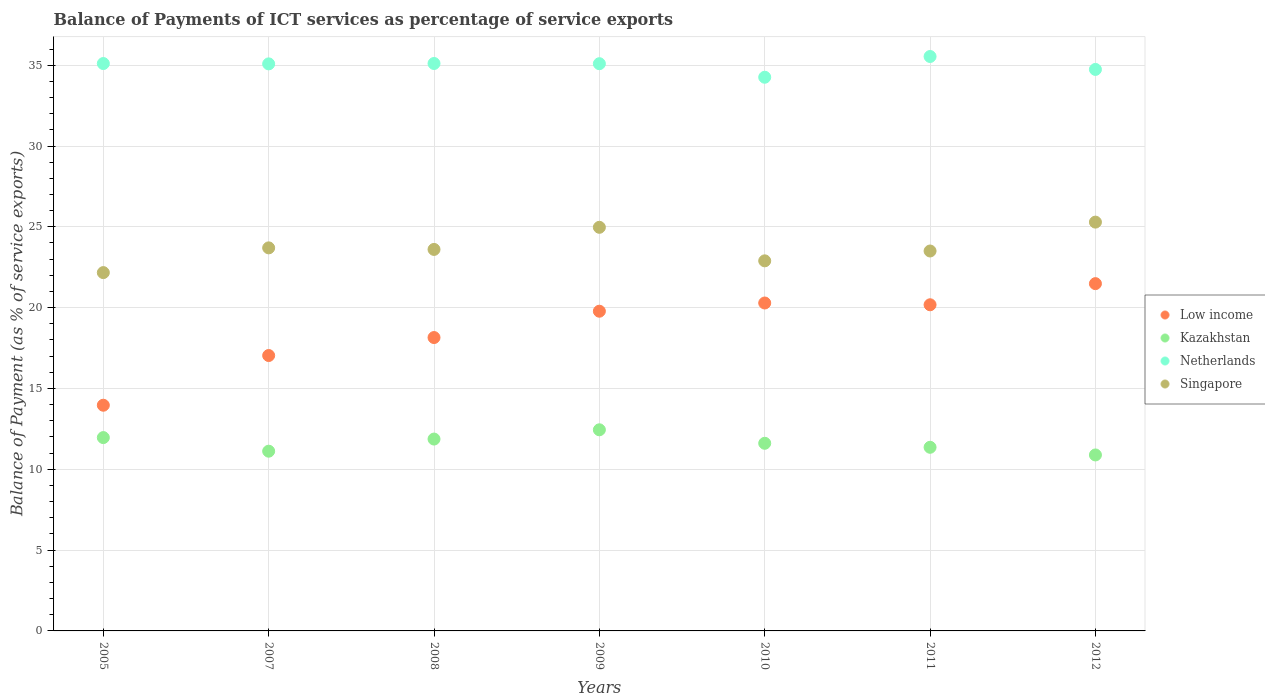Is the number of dotlines equal to the number of legend labels?
Your response must be concise. Yes. What is the balance of payments of ICT services in Netherlands in 2011?
Offer a terse response. 35.54. Across all years, what is the maximum balance of payments of ICT services in Netherlands?
Give a very brief answer. 35.54. Across all years, what is the minimum balance of payments of ICT services in Singapore?
Provide a succinct answer. 22.17. In which year was the balance of payments of ICT services in Kazakhstan maximum?
Provide a short and direct response. 2009. What is the total balance of payments of ICT services in Singapore in the graph?
Make the answer very short. 166.13. What is the difference between the balance of payments of ICT services in Netherlands in 2009 and that in 2011?
Keep it short and to the point. -0.45. What is the difference between the balance of payments of ICT services in Low income in 2009 and the balance of payments of ICT services in Singapore in 2008?
Make the answer very short. -3.82. What is the average balance of payments of ICT services in Low income per year?
Your answer should be compact. 18.7. In the year 2012, what is the difference between the balance of payments of ICT services in Kazakhstan and balance of payments of ICT services in Netherlands?
Offer a terse response. -23.85. What is the ratio of the balance of payments of ICT services in Kazakhstan in 2005 to that in 2009?
Your answer should be compact. 0.96. What is the difference between the highest and the second highest balance of payments of ICT services in Singapore?
Make the answer very short. 0.32. What is the difference between the highest and the lowest balance of payments of ICT services in Kazakhstan?
Ensure brevity in your answer.  1.56. In how many years, is the balance of payments of ICT services in Low income greater than the average balance of payments of ICT services in Low income taken over all years?
Your answer should be compact. 4. Is it the case that in every year, the sum of the balance of payments of ICT services in Netherlands and balance of payments of ICT services in Singapore  is greater than the balance of payments of ICT services in Low income?
Offer a very short reply. Yes. Is the balance of payments of ICT services in Netherlands strictly greater than the balance of payments of ICT services in Singapore over the years?
Make the answer very short. Yes. How many years are there in the graph?
Make the answer very short. 7. Are the values on the major ticks of Y-axis written in scientific E-notation?
Make the answer very short. No. Where does the legend appear in the graph?
Your answer should be very brief. Center right. What is the title of the graph?
Offer a terse response. Balance of Payments of ICT services as percentage of service exports. Does "Tunisia" appear as one of the legend labels in the graph?
Keep it short and to the point. No. What is the label or title of the X-axis?
Make the answer very short. Years. What is the label or title of the Y-axis?
Provide a succinct answer. Balance of Payment (as % of service exports). What is the Balance of Payment (as % of service exports) in Low income in 2005?
Offer a terse response. 13.96. What is the Balance of Payment (as % of service exports) in Kazakhstan in 2005?
Offer a very short reply. 11.96. What is the Balance of Payment (as % of service exports) in Netherlands in 2005?
Provide a succinct answer. 35.1. What is the Balance of Payment (as % of service exports) in Singapore in 2005?
Offer a terse response. 22.17. What is the Balance of Payment (as % of service exports) in Low income in 2007?
Your response must be concise. 17.04. What is the Balance of Payment (as % of service exports) in Kazakhstan in 2007?
Give a very brief answer. 11.12. What is the Balance of Payment (as % of service exports) of Netherlands in 2007?
Offer a very short reply. 35.08. What is the Balance of Payment (as % of service exports) in Singapore in 2007?
Give a very brief answer. 23.7. What is the Balance of Payment (as % of service exports) of Low income in 2008?
Your answer should be compact. 18.15. What is the Balance of Payment (as % of service exports) in Kazakhstan in 2008?
Your answer should be compact. 11.87. What is the Balance of Payment (as % of service exports) of Netherlands in 2008?
Provide a short and direct response. 35.11. What is the Balance of Payment (as % of service exports) of Singapore in 2008?
Your response must be concise. 23.6. What is the Balance of Payment (as % of service exports) of Low income in 2009?
Your answer should be very brief. 19.78. What is the Balance of Payment (as % of service exports) of Kazakhstan in 2009?
Give a very brief answer. 12.44. What is the Balance of Payment (as % of service exports) of Netherlands in 2009?
Provide a short and direct response. 35.09. What is the Balance of Payment (as % of service exports) of Singapore in 2009?
Provide a succinct answer. 24.97. What is the Balance of Payment (as % of service exports) in Low income in 2010?
Your answer should be compact. 20.29. What is the Balance of Payment (as % of service exports) in Kazakhstan in 2010?
Your response must be concise. 11.61. What is the Balance of Payment (as % of service exports) of Netherlands in 2010?
Offer a very short reply. 34.25. What is the Balance of Payment (as % of service exports) of Singapore in 2010?
Provide a short and direct response. 22.9. What is the Balance of Payment (as % of service exports) of Low income in 2011?
Your answer should be compact. 20.18. What is the Balance of Payment (as % of service exports) of Kazakhstan in 2011?
Your answer should be very brief. 11.36. What is the Balance of Payment (as % of service exports) of Netherlands in 2011?
Make the answer very short. 35.54. What is the Balance of Payment (as % of service exports) in Singapore in 2011?
Your answer should be compact. 23.5. What is the Balance of Payment (as % of service exports) of Low income in 2012?
Your answer should be compact. 21.49. What is the Balance of Payment (as % of service exports) of Kazakhstan in 2012?
Your answer should be very brief. 10.89. What is the Balance of Payment (as % of service exports) in Netherlands in 2012?
Offer a terse response. 34.74. What is the Balance of Payment (as % of service exports) of Singapore in 2012?
Your answer should be very brief. 25.29. Across all years, what is the maximum Balance of Payment (as % of service exports) of Low income?
Ensure brevity in your answer.  21.49. Across all years, what is the maximum Balance of Payment (as % of service exports) of Kazakhstan?
Keep it short and to the point. 12.44. Across all years, what is the maximum Balance of Payment (as % of service exports) of Netherlands?
Provide a short and direct response. 35.54. Across all years, what is the maximum Balance of Payment (as % of service exports) of Singapore?
Offer a terse response. 25.29. Across all years, what is the minimum Balance of Payment (as % of service exports) of Low income?
Give a very brief answer. 13.96. Across all years, what is the minimum Balance of Payment (as % of service exports) in Kazakhstan?
Make the answer very short. 10.89. Across all years, what is the minimum Balance of Payment (as % of service exports) in Netherlands?
Your answer should be very brief. 34.25. Across all years, what is the minimum Balance of Payment (as % of service exports) in Singapore?
Your answer should be compact. 22.17. What is the total Balance of Payment (as % of service exports) of Low income in the graph?
Provide a short and direct response. 130.88. What is the total Balance of Payment (as % of service exports) of Kazakhstan in the graph?
Keep it short and to the point. 81.25. What is the total Balance of Payment (as % of service exports) of Netherlands in the graph?
Provide a succinct answer. 244.91. What is the total Balance of Payment (as % of service exports) of Singapore in the graph?
Provide a succinct answer. 166.13. What is the difference between the Balance of Payment (as % of service exports) in Low income in 2005 and that in 2007?
Ensure brevity in your answer.  -3.08. What is the difference between the Balance of Payment (as % of service exports) in Kazakhstan in 2005 and that in 2007?
Give a very brief answer. 0.84. What is the difference between the Balance of Payment (as % of service exports) of Netherlands in 2005 and that in 2007?
Your answer should be compact. 0.02. What is the difference between the Balance of Payment (as % of service exports) in Singapore in 2005 and that in 2007?
Keep it short and to the point. -1.53. What is the difference between the Balance of Payment (as % of service exports) in Low income in 2005 and that in 2008?
Provide a short and direct response. -4.19. What is the difference between the Balance of Payment (as % of service exports) of Kazakhstan in 2005 and that in 2008?
Make the answer very short. 0.09. What is the difference between the Balance of Payment (as % of service exports) of Netherlands in 2005 and that in 2008?
Provide a short and direct response. -0. What is the difference between the Balance of Payment (as % of service exports) of Singapore in 2005 and that in 2008?
Provide a short and direct response. -1.43. What is the difference between the Balance of Payment (as % of service exports) of Low income in 2005 and that in 2009?
Make the answer very short. -5.82. What is the difference between the Balance of Payment (as % of service exports) of Kazakhstan in 2005 and that in 2009?
Ensure brevity in your answer.  -0.48. What is the difference between the Balance of Payment (as % of service exports) of Netherlands in 2005 and that in 2009?
Provide a short and direct response. 0.01. What is the difference between the Balance of Payment (as % of service exports) of Singapore in 2005 and that in 2009?
Your answer should be very brief. -2.8. What is the difference between the Balance of Payment (as % of service exports) of Low income in 2005 and that in 2010?
Offer a very short reply. -6.32. What is the difference between the Balance of Payment (as % of service exports) of Kazakhstan in 2005 and that in 2010?
Give a very brief answer. 0.35. What is the difference between the Balance of Payment (as % of service exports) in Netherlands in 2005 and that in 2010?
Make the answer very short. 0.85. What is the difference between the Balance of Payment (as % of service exports) in Singapore in 2005 and that in 2010?
Offer a very short reply. -0.73. What is the difference between the Balance of Payment (as % of service exports) of Low income in 2005 and that in 2011?
Provide a succinct answer. -6.22. What is the difference between the Balance of Payment (as % of service exports) of Kazakhstan in 2005 and that in 2011?
Make the answer very short. 0.6. What is the difference between the Balance of Payment (as % of service exports) in Netherlands in 2005 and that in 2011?
Your answer should be compact. -0.44. What is the difference between the Balance of Payment (as % of service exports) of Singapore in 2005 and that in 2011?
Give a very brief answer. -1.34. What is the difference between the Balance of Payment (as % of service exports) of Low income in 2005 and that in 2012?
Offer a terse response. -7.52. What is the difference between the Balance of Payment (as % of service exports) in Kazakhstan in 2005 and that in 2012?
Keep it short and to the point. 1.07. What is the difference between the Balance of Payment (as % of service exports) of Netherlands in 2005 and that in 2012?
Your response must be concise. 0.36. What is the difference between the Balance of Payment (as % of service exports) in Singapore in 2005 and that in 2012?
Your answer should be compact. -3.12. What is the difference between the Balance of Payment (as % of service exports) in Low income in 2007 and that in 2008?
Your response must be concise. -1.11. What is the difference between the Balance of Payment (as % of service exports) in Kazakhstan in 2007 and that in 2008?
Make the answer very short. -0.75. What is the difference between the Balance of Payment (as % of service exports) in Netherlands in 2007 and that in 2008?
Your answer should be compact. -0.02. What is the difference between the Balance of Payment (as % of service exports) in Singapore in 2007 and that in 2008?
Your answer should be very brief. 0.1. What is the difference between the Balance of Payment (as % of service exports) in Low income in 2007 and that in 2009?
Your response must be concise. -2.74. What is the difference between the Balance of Payment (as % of service exports) in Kazakhstan in 2007 and that in 2009?
Make the answer very short. -1.32. What is the difference between the Balance of Payment (as % of service exports) in Netherlands in 2007 and that in 2009?
Your answer should be very brief. -0.01. What is the difference between the Balance of Payment (as % of service exports) of Singapore in 2007 and that in 2009?
Your answer should be very brief. -1.27. What is the difference between the Balance of Payment (as % of service exports) of Low income in 2007 and that in 2010?
Offer a terse response. -3.25. What is the difference between the Balance of Payment (as % of service exports) in Kazakhstan in 2007 and that in 2010?
Make the answer very short. -0.49. What is the difference between the Balance of Payment (as % of service exports) of Netherlands in 2007 and that in 2010?
Offer a very short reply. 0.83. What is the difference between the Balance of Payment (as % of service exports) of Singapore in 2007 and that in 2010?
Your answer should be compact. 0.8. What is the difference between the Balance of Payment (as % of service exports) in Low income in 2007 and that in 2011?
Offer a terse response. -3.14. What is the difference between the Balance of Payment (as % of service exports) in Kazakhstan in 2007 and that in 2011?
Your answer should be very brief. -0.24. What is the difference between the Balance of Payment (as % of service exports) in Netherlands in 2007 and that in 2011?
Keep it short and to the point. -0.46. What is the difference between the Balance of Payment (as % of service exports) of Singapore in 2007 and that in 2011?
Keep it short and to the point. 0.19. What is the difference between the Balance of Payment (as % of service exports) in Low income in 2007 and that in 2012?
Provide a short and direct response. -4.45. What is the difference between the Balance of Payment (as % of service exports) in Kazakhstan in 2007 and that in 2012?
Offer a very short reply. 0.23. What is the difference between the Balance of Payment (as % of service exports) of Netherlands in 2007 and that in 2012?
Your answer should be very brief. 0.34. What is the difference between the Balance of Payment (as % of service exports) of Singapore in 2007 and that in 2012?
Keep it short and to the point. -1.59. What is the difference between the Balance of Payment (as % of service exports) of Low income in 2008 and that in 2009?
Ensure brevity in your answer.  -1.63. What is the difference between the Balance of Payment (as % of service exports) in Kazakhstan in 2008 and that in 2009?
Ensure brevity in your answer.  -0.57. What is the difference between the Balance of Payment (as % of service exports) in Netherlands in 2008 and that in 2009?
Your answer should be compact. 0.01. What is the difference between the Balance of Payment (as % of service exports) of Singapore in 2008 and that in 2009?
Provide a succinct answer. -1.37. What is the difference between the Balance of Payment (as % of service exports) in Low income in 2008 and that in 2010?
Provide a succinct answer. -2.14. What is the difference between the Balance of Payment (as % of service exports) in Kazakhstan in 2008 and that in 2010?
Provide a succinct answer. 0.26. What is the difference between the Balance of Payment (as % of service exports) of Netherlands in 2008 and that in 2010?
Offer a terse response. 0.85. What is the difference between the Balance of Payment (as % of service exports) in Singapore in 2008 and that in 2010?
Make the answer very short. 0.71. What is the difference between the Balance of Payment (as % of service exports) of Low income in 2008 and that in 2011?
Offer a very short reply. -2.03. What is the difference between the Balance of Payment (as % of service exports) in Kazakhstan in 2008 and that in 2011?
Provide a succinct answer. 0.51. What is the difference between the Balance of Payment (as % of service exports) of Netherlands in 2008 and that in 2011?
Keep it short and to the point. -0.43. What is the difference between the Balance of Payment (as % of service exports) of Singapore in 2008 and that in 2011?
Offer a very short reply. 0.1. What is the difference between the Balance of Payment (as % of service exports) in Low income in 2008 and that in 2012?
Provide a short and direct response. -3.34. What is the difference between the Balance of Payment (as % of service exports) of Kazakhstan in 2008 and that in 2012?
Your answer should be very brief. 0.98. What is the difference between the Balance of Payment (as % of service exports) of Netherlands in 2008 and that in 2012?
Keep it short and to the point. 0.37. What is the difference between the Balance of Payment (as % of service exports) of Singapore in 2008 and that in 2012?
Give a very brief answer. -1.69. What is the difference between the Balance of Payment (as % of service exports) of Low income in 2009 and that in 2010?
Offer a very short reply. -0.51. What is the difference between the Balance of Payment (as % of service exports) of Kazakhstan in 2009 and that in 2010?
Make the answer very short. 0.83. What is the difference between the Balance of Payment (as % of service exports) of Netherlands in 2009 and that in 2010?
Your answer should be compact. 0.84. What is the difference between the Balance of Payment (as % of service exports) of Singapore in 2009 and that in 2010?
Offer a terse response. 2.07. What is the difference between the Balance of Payment (as % of service exports) in Low income in 2009 and that in 2011?
Give a very brief answer. -0.4. What is the difference between the Balance of Payment (as % of service exports) in Kazakhstan in 2009 and that in 2011?
Your response must be concise. 1.08. What is the difference between the Balance of Payment (as % of service exports) of Netherlands in 2009 and that in 2011?
Ensure brevity in your answer.  -0.45. What is the difference between the Balance of Payment (as % of service exports) in Singapore in 2009 and that in 2011?
Keep it short and to the point. 1.47. What is the difference between the Balance of Payment (as % of service exports) in Low income in 2009 and that in 2012?
Offer a very short reply. -1.71. What is the difference between the Balance of Payment (as % of service exports) of Kazakhstan in 2009 and that in 2012?
Your answer should be compact. 1.56. What is the difference between the Balance of Payment (as % of service exports) of Netherlands in 2009 and that in 2012?
Ensure brevity in your answer.  0.35. What is the difference between the Balance of Payment (as % of service exports) of Singapore in 2009 and that in 2012?
Offer a very short reply. -0.32. What is the difference between the Balance of Payment (as % of service exports) of Low income in 2010 and that in 2011?
Give a very brief answer. 0.11. What is the difference between the Balance of Payment (as % of service exports) in Kazakhstan in 2010 and that in 2011?
Make the answer very short. 0.25. What is the difference between the Balance of Payment (as % of service exports) in Netherlands in 2010 and that in 2011?
Your answer should be compact. -1.28. What is the difference between the Balance of Payment (as % of service exports) in Singapore in 2010 and that in 2011?
Keep it short and to the point. -0.61. What is the difference between the Balance of Payment (as % of service exports) in Low income in 2010 and that in 2012?
Ensure brevity in your answer.  -1.2. What is the difference between the Balance of Payment (as % of service exports) of Kazakhstan in 2010 and that in 2012?
Make the answer very short. 0.72. What is the difference between the Balance of Payment (as % of service exports) in Netherlands in 2010 and that in 2012?
Make the answer very short. -0.48. What is the difference between the Balance of Payment (as % of service exports) of Singapore in 2010 and that in 2012?
Your answer should be compact. -2.4. What is the difference between the Balance of Payment (as % of service exports) in Low income in 2011 and that in 2012?
Provide a short and direct response. -1.31. What is the difference between the Balance of Payment (as % of service exports) in Kazakhstan in 2011 and that in 2012?
Your response must be concise. 0.47. What is the difference between the Balance of Payment (as % of service exports) of Netherlands in 2011 and that in 2012?
Provide a succinct answer. 0.8. What is the difference between the Balance of Payment (as % of service exports) in Singapore in 2011 and that in 2012?
Your response must be concise. -1.79. What is the difference between the Balance of Payment (as % of service exports) of Low income in 2005 and the Balance of Payment (as % of service exports) of Kazakhstan in 2007?
Provide a succinct answer. 2.84. What is the difference between the Balance of Payment (as % of service exports) of Low income in 2005 and the Balance of Payment (as % of service exports) of Netherlands in 2007?
Offer a terse response. -21.12. What is the difference between the Balance of Payment (as % of service exports) in Low income in 2005 and the Balance of Payment (as % of service exports) in Singapore in 2007?
Ensure brevity in your answer.  -9.74. What is the difference between the Balance of Payment (as % of service exports) in Kazakhstan in 2005 and the Balance of Payment (as % of service exports) in Netherlands in 2007?
Keep it short and to the point. -23.12. What is the difference between the Balance of Payment (as % of service exports) in Kazakhstan in 2005 and the Balance of Payment (as % of service exports) in Singapore in 2007?
Give a very brief answer. -11.74. What is the difference between the Balance of Payment (as % of service exports) in Netherlands in 2005 and the Balance of Payment (as % of service exports) in Singapore in 2007?
Your answer should be compact. 11.4. What is the difference between the Balance of Payment (as % of service exports) in Low income in 2005 and the Balance of Payment (as % of service exports) in Kazakhstan in 2008?
Your answer should be very brief. 2.09. What is the difference between the Balance of Payment (as % of service exports) in Low income in 2005 and the Balance of Payment (as % of service exports) in Netherlands in 2008?
Provide a short and direct response. -21.14. What is the difference between the Balance of Payment (as % of service exports) of Low income in 2005 and the Balance of Payment (as % of service exports) of Singapore in 2008?
Your answer should be compact. -9.64. What is the difference between the Balance of Payment (as % of service exports) in Kazakhstan in 2005 and the Balance of Payment (as % of service exports) in Netherlands in 2008?
Offer a terse response. -23.14. What is the difference between the Balance of Payment (as % of service exports) in Kazakhstan in 2005 and the Balance of Payment (as % of service exports) in Singapore in 2008?
Ensure brevity in your answer.  -11.64. What is the difference between the Balance of Payment (as % of service exports) of Netherlands in 2005 and the Balance of Payment (as % of service exports) of Singapore in 2008?
Provide a succinct answer. 11.5. What is the difference between the Balance of Payment (as % of service exports) of Low income in 2005 and the Balance of Payment (as % of service exports) of Kazakhstan in 2009?
Keep it short and to the point. 1.52. What is the difference between the Balance of Payment (as % of service exports) in Low income in 2005 and the Balance of Payment (as % of service exports) in Netherlands in 2009?
Offer a very short reply. -21.13. What is the difference between the Balance of Payment (as % of service exports) of Low income in 2005 and the Balance of Payment (as % of service exports) of Singapore in 2009?
Ensure brevity in your answer.  -11.01. What is the difference between the Balance of Payment (as % of service exports) of Kazakhstan in 2005 and the Balance of Payment (as % of service exports) of Netherlands in 2009?
Provide a short and direct response. -23.13. What is the difference between the Balance of Payment (as % of service exports) in Kazakhstan in 2005 and the Balance of Payment (as % of service exports) in Singapore in 2009?
Your answer should be very brief. -13.01. What is the difference between the Balance of Payment (as % of service exports) of Netherlands in 2005 and the Balance of Payment (as % of service exports) of Singapore in 2009?
Give a very brief answer. 10.13. What is the difference between the Balance of Payment (as % of service exports) of Low income in 2005 and the Balance of Payment (as % of service exports) of Kazakhstan in 2010?
Provide a succinct answer. 2.35. What is the difference between the Balance of Payment (as % of service exports) in Low income in 2005 and the Balance of Payment (as % of service exports) in Netherlands in 2010?
Offer a terse response. -20.29. What is the difference between the Balance of Payment (as % of service exports) of Low income in 2005 and the Balance of Payment (as % of service exports) of Singapore in 2010?
Ensure brevity in your answer.  -8.93. What is the difference between the Balance of Payment (as % of service exports) of Kazakhstan in 2005 and the Balance of Payment (as % of service exports) of Netherlands in 2010?
Provide a succinct answer. -22.29. What is the difference between the Balance of Payment (as % of service exports) in Kazakhstan in 2005 and the Balance of Payment (as % of service exports) in Singapore in 2010?
Your response must be concise. -10.93. What is the difference between the Balance of Payment (as % of service exports) in Netherlands in 2005 and the Balance of Payment (as % of service exports) in Singapore in 2010?
Provide a short and direct response. 12.21. What is the difference between the Balance of Payment (as % of service exports) in Low income in 2005 and the Balance of Payment (as % of service exports) in Kazakhstan in 2011?
Provide a short and direct response. 2.6. What is the difference between the Balance of Payment (as % of service exports) of Low income in 2005 and the Balance of Payment (as % of service exports) of Netherlands in 2011?
Offer a terse response. -21.58. What is the difference between the Balance of Payment (as % of service exports) in Low income in 2005 and the Balance of Payment (as % of service exports) in Singapore in 2011?
Give a very brief answer. -9.54. What is the difference between the Balance of Payment (as % of service exports) of Kazakhstan in 2005 and the Balance of Payment (as % of service exports) of Netherlands in 2011?
Provide a succinct answer. -23.58. What is the difference between the Balance of Payment (as % of service exports) of Kazakhstan in 2005 and the Balance of Payment (as % of service exports) of Singapore in 2011?
Ensure brevity in your answer.  -11.54. What is the difference between the Balance of Payment (as % of service exports) of Netherlands in 2005 and the Balance of Payment (as % of service exports) of Singapore in 2011?
Keep it short and to the point. 11.6. What is the difference between the Balance of Payment (as % of service exports) of Low income in 2005 and the Balance of Payment (as % of service exports) of Kazakhstan in 2012?
Provide a succinct answer. 3.08. What is the difference between the Balance of Payment (as % of service exports) in Low income in 2005 and the Balance of Payment (as % of service exports) in Netherlands in 2012?
Keep it short and to the point. -20.78. What is the difference between the Balance of Payment (as % of service exports) of Low income in 2005 and the Balance of Payment (as % of service exports) of Singapore in 2012?
Offer a terse response. -11.33. What is the difference between the Balance of Payment (as % of service exports) of Kazakhstan in 2005 and the Balance of Payment (as % of service exports) of Netherlands in 2012?
Make the answer very short. -22.78. What is the difference between the Balance of Payment (as % of service exports) of Kazakhstan in 2005 and the Balance of Payment (as % of service exports) of Singapore in 2012?
Your response must be concise. -13.33. What is the difference between the Balance of Payment (as % of service exports) in Netherlands in 2005 and the Balance of Payment (as % of service exports) in Singapore in 2012?
Offer a very short reply. 9.81. What is the difference between the Balance of Payment (as % of service exports) in Low income in 2007 and the Balance of Payment (as % of service exports) in Kazakhstan in 2008?
Offer a very short reply. 5.17. What is the difference between the Balance of Payment (as % of service exports) in Low income in 2007 and the Balance of Payment (as % of service exports) in Netherlands in 2008?
Provide a short and direct response. -18.07. What is the difference between the Balance of Payment (as % of service exports) of Low income in 2007 and the Balance of Payment (as % of service exports) of Singapore in 2008?
Keep it short and to the point. -6.56. What is the difference between the Balance of Payment (as % of service exports) in Kazakhstan in 2007 and the Balance of Payment (as % of service exports) in Netherlands in 2008?
Provide a succinct answer. -23.99. What is the difference between the Balance of Payment (as % of service exports) in Kazakhstan in 2007 and the Balance of Payment (as % of service exports) in Singapore in 2008?
Keep it short and to the point. -12.48. What is the difference between the Balance of Payment (as % of service exports) of Netherlands in 2007 and the Balance of Payment (as % of service exports) of Singapore in 2008?
Provide a short and direct response. 11.48. What is the difference between the Balance of Payment (as % of service exports) in Low income in 2007 and the Balance of Payment (as % of service exports) in Kazakhstan in 2009?
Your response must be concise. 4.6. What is the difference between the Balance of Payment (as % of service exports) of Low income in 2007 and the Balance of Payment (as % of service exports) of Netherlands in 2009?
Make the answer very short. -18.05. What is the difference between the Balance of Payment (as % of service exports) in Low income in 2007 and the Balance of Payment (as % of service exports) in Singapore in 2009?
Offer a very short reply. -7.93. What is the difference between the Balance of Payment (as % of service exports) in Kazakhstan in 2007 and the Balance of Payment (as % of service exports) in Netherlands in 2009?
Provide a succinct answer. -23.97. What is the difference between the Balance of Payment (as % of service exports) of Kazakhstan in 2007 and the Balance of Payment (as % of service exports) of Singapore in 2009?
Your response must be concise. -13.85. What is the difference between the Balance of Payment (as % of service exports) of Netherlands in 2007 and the Balance of Payment (as % of service exports) of Singapore in 2009?
Provide a succinct answer. 10.11. What is the difference between the Balance of Payment (as % of service exports) of Low income in 2007 and the Balance of Payment (as % of service exports) of Kazakhstan in 2010?
Ensure brevity in your answer.  5.43. What is the difference between the Balance of Payment (as % of service exports) of Low income in 2007 and the Balance of Payment (as % of service exports) of Netherlands in 2010?
Offer a terse response. -17.22. What is the difference between the Balance of Payment (as % of service exports) in Low income in 2007 and the Balance of Payment (as % of service exports) in Singapore in 2010?
Make the answer very short. -5.86. What is the difference between the Balance of Payment (as % of service exports) in Kazakhstan in 2007 and the Balance of Payment (as % of service exports) in Netherlands in 2010?
Give a very brief answer. -23.13. What is the difference between the Balance of Payment (as % of service exports) in Kazakhstan in 2007 and the Balance of Payment (as % of service exports) in Singapore in 2010?
Give a very brief answer. -11.78. What is the difference between the Balance of Payment (as % of service exports) in Netherlands in 2007 and the Balance of Payment (as % of service exports) in Singapore in 2010?
Offer a terse response. 12.19. What is the difference between the Balance of Payment (as % of service exports) of Low income in 2007 and the Balance of Payment (as % of service exports) of Kazakhstan in 2011?
Your answer should be compact. 5.68. What is the difference between the Balance of Payment (as % of service exports) of Low income in 2007 and the Balance of Payment (as % of service exports) of Netherlands in 2011?
Give a very brief answer. -18.5. What is the difference between the Balance of Payment (as % of service exports) of Low income in 2007 and the Balance of Payment (as % of service exports) of Singapore in 2011?
Give a very brief answer. -6.47. What is the difference between the Balance of Payment (as % of service exports) in Kazakhstan in 2007 and the Balance of Payment (as % of service exports) in Netherlands in 2011?
Keep it short and to the point. -24.42. What is the difference between the Balance of Payment (as % of service exports) of Kazakhstan in 2007 and the Balance of Payment (as % of service exports) of Singapore in 2011?
Offer a very short reply. -12.38. What is the difference between the Balance of Payment (as % of service exports) of Netherlands in 2007 and the Balance of Payment (as % of service exports) of Singapore in 2011?
Provide a short and direct response. 11.58. What is the difference between the Balance of Payment (as % of service exports) in Low income in 2007 and the Balance of Payment (as % of service exports) in Kazakhstan in 2012?
Provide a short and direct response. 6.15. What is the difference between the Balance of Payment (as % of service exports) in Low income in 2007 and the Balance of Payment (as % of service exports) in Netherlands in 2012?
Your answer should be compact. -17.7. What is the difference between the Balance of Payment (as % of service exports) of Low income in 2007 and the Balance of Payment (as % of service exports) of Singapore in 2012?
Keep it short and to the point. -8.25. What is the difference between the Balance of Payment (as % of service exports) of Kazakhstan in 2007 and the Balance of Payment (as % of service exports) of Netherlands in 2012?
Your response must be concise. -23.62. What is the difference between the Balance of Payment (as % of service exports) of Kazakhstan in 2007 and the Balance of Payment (as % of service exports) of Singapore in 2012?
Provide a short and direct response. -14.17. What is the difference between the Balance of Payment (as % of service exports) of Netherlands in 2007 and the Balance of Payment (as % of service exports) of Singapore in 2012?
Provide a short and direct response. 9.79. What is the difference between the Balance of Payment (as % of service exports) in Low income in 2008 and the Balance of Payment (as % of service exports) in Kazakhstan in 2009?
Your answer should be compact. 5.71. What is the difference between the Balance of Payment (as % of service exports) in Low income in 2008 and the Balance of Payment (as % of service exports) in Netherlands in 2009?
Keep it short and to the point. -16.94. What is the difference between the Balance of Payment (as % of service exports) of Low income in 2008 and the Balance of Payment (as % of service exports) of Singapore in 2009?
Provide a succinct answer. -6.82. What is the difference between the Balance of Payment (as % of service exports) of Kazakhstan in 2008 and the Balance of Payment (as % of service exports) of Netherlands in 2009?
Provide a succinct answer. -23.22. What is the difference between the Balance of Payment (as % of service exports) in Kazakhstan in 2008 and the Balance of Payment (as % of service exports) in Singapore in 2009?
Offer a very short reply. -13.1. What is the difference between the Balance of Payment (as % of service exports) of Netherlands in 2008 and the Balance of Payment (as % of service exports) of Singapore in 2009?
Offer a terse response. 10.14. What is the difference between the Balance of Payment (as % of service exports) in Low income in 2008 and the Balance of Payment (as % of service exports) in Kazakhstan in 2010?
Keep it short and to the point. 6.54. What is the difference between the Balance of Payment (as % of service exports) in Low income in 2008 and the Balance of Payment (as % of service exports) in Netherlands in 2010?
Give a very brief answer. -16.1. What is the difference between the Balance of Payment (as % of service exports) in Low income in 2008 and the Balance of Payment (as % of service exports) in Singapore in 2010?
Your response must be concise. -4.75. What is the difference between the Balance of Payment (as % of service exports) of Kazakhstan in 2008 and the Balance of Payment (as % of service exports) of Netherlands in 2010?
Provide a succinct answer. -22.38. What is the difference between the Balance of Payment (as % of service exports) in Kazakhstan in 2008 and the Balance of Payment (as % of service exports) in Singapore in 2010?
Ensure brevity in your answer.  -11.03. What is the difference between the Balance of Payment (as % of service exports) of Netherlands in 2008 and the Balance of Payment (as % of service exports) of Singapore in 2010?
Your response must be concise. 12.21. What is the difference between the Balance of Payment (as % of service exports) in Low income in 2008 and the Balance of Payment (as % of service exports) in Kazakhstan in 2011?
Offer a terse response. 6.79. What is the difference between the Balance of Payment (as % of service exports) of Low income in 2008 and the Balance of Payment (as % of service exports) of Netherlands in 2011?
Offer a terse response. -17.39. What is the difference between the Balance of Payment (as % of service exports) in Low income in 2008 and the Balance of Payment (as % of service exports) in Singapore in 2011?
Ensure brevity in your answer.  -5.35. What is the difference between the Balance of Payment (as % of service exports) of Kazakhstan in 2008 and the Balance of Payment (as % of service exports) of Netherlands in 2011?
Give a very brief answer. -23.67. What is the difference between the Balance of Payment (as % of service exports) in Kazakhstan in 2008 and the Balance of Payment (as % of service exports) in Singapore in 2011?
Offer a very short reply. -11.63. What is the difference between the Balance of Payment (as % of service exports) in Netherlands in 2008 and the Balance of Payment (as % of service exports) in Singapore in 2011?
Offer a very short reply. 11.6. What is the difference between the Balance of Payment (as % of service exports) in Low income in 2008 and the Balance of Payment (as % of service exports) in Kazakhstan in 2012?
Keep it short and to the point. 7.26. What is the difference between the Balance of Payment (as % of service exports) of Low income in 2008 and the Balance of Payment (as % of service exports) of Netherlands in 2012?
Make the answer very short. -16.59. What is the difference between the Balance of Payment (as % of service exports) in Low income in 2008 and the Balance of Payment (as % of service exports) in Singapore in 2012?
Give a very brief answer. -7.14. What is the difference between the Balance of Payment (as % of service exports) in Kazakhstan in 2008 and the Balance of Payment (as % of service exports) in Netherlands in 2012?
Provide a short and direct response. -22.87. What is the difference between the Balance of Payment (as % of service exports) in Kazakhstan in 2008 and the Balance of Payment (as % of service exports) in Singapore in 2012?
Provide a succinct answer. -13.42. What is the difference between the Balance of Payment (as % of service exports) of Netherlands in 2008 and the Balance of Payment (as % of service exports) of Singapore in 2012?
Offer a terse response. 9.81. What is the difference between the Balance of Payment (as % of service exports) of Low income in 2009 and the Balance of Payment (as % of service exports) of Kazakhstan in 2010?
Your answer should be compact. 8.17. What is the difference between the Balance of Payment (as % of service exports) of Low income in 2009 and the Balance of Payment (as % of service exports) of Netherlands in 2010?
Keep it short and to the point. -14.48. What is the difference between the Balance of Payment (as % of service exports) of Low income in 2009 and the Balance of Payment (as % of service exports) of Singapore in 2010?
Offer a terse response. -3.12. What is the difference between the Balance of Payment (as % of service exports) of Kazakhstan in 2009 and the Balance of Payment (as % of service exports) of Netherlands in 2010?
Offer a very short reply. -21.81. What is the difference between the Balance of Payment (as % of service exports) in Kazakhstan in 2009 and the Balance of Payment (as % of service exports) in Singapore in 2010?
Offer a terse response. -10.45. What is the difference between the Balance of Payment (as % of service exports) of Netherlands in 2009 and the Balance of Payment (as % of service exports) of Singapore in 2010?
Provide a succinct answer. 12.2. What is the difference between the Balance of Payment (as % of service exports) of Low income in 2009 and the Balance of Payment (as % of service exports) of Kazakhstan in 2011?
Your response must be concise. 8.42. What is the difference between the Balance of Payment (as % of service exports) of Low income in 2009 and the Balance of Payment (as % of service exports) of Netherlands in 2011?
Your answer should be very brief. -15.76. What is the difference between the Balance of Payment (as % of service exports) in Low income in 2009 and the Balance of Payment (as % of service exports) in Singapore in 2011?
Provide a succinct answer. -3.73. What is the difference between the Balance of Payment (as % of service exports) of Kazakhstan in 2009 and the Balance of Payment (as % of service exports) of Netherlands in 2011?
Provide a succinct answer. -23.1. What is the difference between the Balance of Payment (as % of service exports) in Kazakhstan in 2009 and the Balance of Payment (as % of service exports) in Singapore in 2011?
Make the answer very short. -11.06. What is the difference between the Balance of Payment (as % of service exports) in Netherlands in 2009 and the Balance of Payment (as % of service exports) in Singapore in 2011?
Your response must be concise. 11.59. What is the difference between the Balance of Payment (as % of service exports) of Low income in 2009 and the Balance of Payment (as % of service exports) of Kazakhstan in 2012?
Keep it short and to the point. 8.89. What is the difference between the Balance of Payment (as % of service exports) of Low income in 2009 and the Balance of Payment (as % of service exports) of Netherlands in 2012?
Give a very brief answer. -14.96. What is the difference between the Balance of Payment (as % of service exports) in Low income in 2009 and the Balance of Payment (as % of service exports) in Singapore in 2012?
Offer a very short reply. -5.51. What is the difference between the Balance of Payment (as % of service exports) in Kazakhstan in 2009 and the Balance of Payment (as % of service exports) in Netherlands in 2012?
Provide a succinct answer. -22.3. What is the difference between the Balance of Payment (as % of service exports) of Kazakhstan in 2009 and the Balance of Payment (as % of service exports) of Singapore in 2012?
Provide a short and direct response. -12.85. What is the difference between the Balance of Payment (as % of service exports) in Netherlands in 2009 and the Balance of Payment (as % of service exports) in Singapore in 2012?
Make the answer very short. 9.8. What is the difference between the Balance of Payment (as % of service exports) of Low income in 2010 and the Balance of Payment (as % of service exports) of Kazakhstan in 2011?
Provide a succinct answer. 8.93. What is the difference between the Balance of Payment (as % of service exports) in Low income in 2010 and the Balance of Payment (as % of service exports) in Netherlands in 2011?
Make the answer very short. -15.25. What is the difference between the Balance of Payment (as % of service exports) in Low income in 2010 and the Balance of Payment (as % of service exports) in Singapore in 2011?
Keep it short and to the point. -3.22. What is the difference between the Balance of Payment (as % of service exports) of Kazakhstan in 2010 and the Balance of Payment (as % of service exports) of Netherlands in 2011?
Provide a succinct answer. -23.93. What is the difference between the Balance of Payment (as % of service exports) of Kazakhstan in 2010 and the Balance of Payment (as % of service exports) of Singapore in 2011?
Provide a succinct answer. -11.9. What is the difference between the Balance of Payment (as % of service exports) of Netherlands in 2010 and the Balance of Payment (as % of service exports) of Singapore in 2011?
Offer a very short reply. 10.75. What is the difference between the Balance of Payment (as % of service exports) in Low income in 2010 and the Balance of Payment (as % of service exports) in Kazakhstan in 2012?
Keep it short and to the point. 9.4. What is the difference between the Balance of Payment (as % of service exports) in Low income in 2010 and the Balance of Payment (as % of service exports) in Netherlands in 2012?
Your answer should be compact. -14.45. What is the difference between the Balance of Payment (as % of service exports) of Low income in 2010 and the Balance of Payment (as % of service exports) of Singapore in 2012?
Make the answer very short. -5. What is the difference between the Balance of Payment (as % of service exports) in Kazakhstan in 2010 and the Balance of Payment (as % of service exports) in Netherlands in 2012?
Provide a short and direct response. -23.13. What is the difference between the Balance of Payment (as % of service exports) in Kazakhstan in 2010 and the Balance of Payment (as % of service exports) in Singapore in 2012?
Your answer should be very brief. -13.68. What is the difference between the Balance of Payment (as % of service exports) of Netherlands in 2010 and the Balance of Payment (as % of service exports) of Singapore in 2012?
Make the answer very short. 8.96. What is the difference between the Balance of Payment (as % of service exports) in Low income in 2011 and the Balance of Payment (as % of service exports) in Kazakhstan in 2012?
Ensure brevity in your answer.  9.29. What is the difference between the Balance of Payment (as % of service exports) in Low income in 2011 and the Balance of Payment (as % of service exports) in Netherlands in 2012?
Keep it short and to the point. -14.56. What is the difference between the Balance of Payment (as % of service exports) of Low income in 2011 and the Balance of Payment (as % of service exports) of Singapore in 2012?
Make the answer very short. -5.11. What is the difference between the Balance of Payment (as % of service exports) in Kazakhstan in 2011 and the Balance of Payment (as % of service exports) in Netherlands in 2012?
Give a very brief answer. -23.38. What is the difference between the Balance of Payment (as % of service exports) of Kazakhstan in 2011 and the Balance of Payment (as % of service exports) of Singapore in 2012?
Your response must be concise. -13.93. What is the difference between the Balance of Payment (as % of service exports) of Netherlands in 2011 and the Balance of Payment (as % of service exports) of Singapore in 2012?
Ensure brevity in your answer.  10.25. What is the average Balance of Payment (as % of service exports) in Low income per year?
Give a very brief answer. 18.7. What is the average Balance of Payment (as % of service exports) of Kazakhstan per year?
Offer a terse response. 11.61. What is the average Balance of Payment (as % of service exports) in Netherlands per year?
Provide a succinct answer. 34.99. What is the average Balance of Payment (as % of service exports) in Singapore per year?
Make the answer very short. 23.73. In the year 2005, what is the difference between the Balance of Payment (as % of service exports) in Low income and Balance of Payment (as % of service exports) in Kazakhstan?
Make the answer very short. 2. In the year 2005, what is the difference between the Balance of Payment (as % of service exports) in Low income and Balance of Payment (as % of service exports) in Netherlands?
Provide a short and direct response. -21.14. In the year 2005, what is the difference between the Balance of Payment (as % of service exports) of Low income and Balance of Payment (as % of service exports) of Singapore?
Your answer should be very brief. -8.21. In the year 2005, what is the difference between the Balance of Payment (as % of service exports) in Kazakhstan and Balance of Payment (as % of service exports) in Netherlands?
Your answer should be very brief. -23.14. In the year 2005, what is the difference between the Balance of Payment (as % of service exports) of Kazakhstan and Balance of Payment (as % of service exports) of Singapore?
Your answer should be very brief. -10.21. In the year 2005, what is the difference between the Balance of Payment (as % of service exports) in Netherlands and Balance of Payment (as % of service exports) in Singapore?
Ensure brevity in your answer.  12.93. In the year 2007, what is the difference between the Balance of Payment (as % of service exports) of Low income and Balance of Payment (as % of service exports) of Kazakhstan?
Your response must be concise. 5.92. In the year 2007, what is the difference between the Balance of Payment (as % of service exports) in Low income and Balance of Payment (as % of service exports) in Netherlands?
Keep it short and to the point. -18.04. In the year 2007, what is the difference between the Balance of Payment (as % of service exports) of Low income and Balance of Payment (as % of service exports) of Singapore?
Give a very brief answer. -6.66. In the year 2007, what is the difference between the Balance of Payment (as % of service exports) in Kazakhstan and Balance of Payment (as % of service exports) in Netherlands?
Keep it short and to the point. -23.96. In the year 2007, what is the difference between the Balance of Payment (as % of service exports) of Kazakhstan and Balance of Payment (as % of service exports) of Singapore?
Provide a succinct answer. -12.58. In the year 2007, what is the difference between the Balance of Payment (as % of service exports) of Netherlands and Balance of Payment (as % of service exports) of Singapore?
Ensure brevity in your answer.  11.38. In the year 2008, what is the difference between the Balance of Payment (as % of service exports) of Low income and Balance of Payment (as % of service exports) of Kazakhstan?
Your response must be concise. 6.28. In the year 2008, what is the difference between the Balance of Payment (as % of service exports) in Low income and Balance of Payment (as % of service exports) in Netherlands?
Provide a succinct answer. -16.96. In the year 2008, what is the difference between the Balance of Payment (as % of service exports) in Low income and Balance of Payment (as % of service exports) in Singapore?
Your response must be concise. -5.45. In the year 2008, what is the difference between the Balance of Payment (as % of service exports) in Kazakhstan and Balance of Payment (as % of service exports) in Netherlands?
Give a very brief answer. -23.24. In the year 2008, what is the difference between the Balance of Payment (as % of service exports) in Kazakhstan and Balance of Payment (as % of service exports) in Singapore?
Your answer should be compact. -11.73. In the year 2008, what is the difference between the Balance of Payment (as % of service exports) in Netherlands and Balance of Payment (as % of service exports) in Singapore?
Ensure brevity in your answer.  11.5. In the year 2009, what is the difference between the Balance of Payment (as % of service exports) of Low income and Balance of Payment (as % of service exports) of Kazakhstan?
Give a very brief answer. 7.34. In the year 2009, what is the difference between the Balance of Payment (as % of service exports) in Low income and Balance of Payment (as % of service exports) in Netherlands?
Keep it short and to the point. -15.31. In the year 2009, what is the difference between the Balance of Payment (as % of service exports) in Low income and Balance of Payment (as % of service exports) in Singapore?
Give a very brief answer. -5.19. In the year 2009, what is the difference between the Balance of Payment (as % of service exports) in Kazakhstan and Balance of Payment (as % of service exports) in Netherlands?
Give a very brief answer. -22.65. In the year 2009, what is the difference between the Balance of Payment (as % of service exports) of Kazakhstan and Balance of Payment (as % of service exports) of Singapore?
Provide a short and direct response. -12.53. In the year 2009, what is the difference between the Balance of Payment (as % of service exports) in Netherlands and Balance of Payment (as % of service exports) in Singapore?
Your response must be concise. 10.12. In the year 2010, what is the difference between the Balance of Payment (as % of service exports) in Low income and Balance of Payment (as % of service exports) in Kazakhstan?
Ensure brevity in your answer.  8.68. In the year 2010, what is the difference between the Balance of Payment (as % of service exports) in Low income and Balance of Payment (as % of service exports) in Netherlands?
Provide a succinct answer. -13.97. In the year 2010, what is the difference between the Balance of Payment (as % of service exports) in Low income and Balance of Payment (as % of service exports) in Singapore?
Your answer should be compact. -2.61. In the year 2010, what is the difference between the Balance of Payment (as % of service exports) of Kazakhstan and Balance of Payment (as % of service exports) of Netherlands?
Offer a very short reply. -22.65. In the year 2010, what is the difference between the Balance of Payment (as % of service exports) of Kazakhstan and Balance of Payment (as % of service exports) of Singapore?
Offer a terse response. -11.29. In the year 2010, what is the difference between the Balance of Payment (as % of service exports) of Netherlands and Balance of Payment (as % of service exports) of Singapore?
Your answer should be compact. 11.36. In the year 2011, what is the difference between the Balance of Payment (as % of service exports) of Low income and Balance of Payment (as % of service exports) of Kazakhstan?
Your response must be concise. 8.82. In the year 2011, what is the difference between the Balance of Payment (as % of service exports) in Low income and Balance of Payment (as % of service exports) in Netherlands?
Ensure brevity in your answer.  -15.36. In the year 2011, what is the difference between the Balance of Payment (as % of service exports) in Low income and Balance of Payment (as % of service exports) in Singapore?
Your answer should be compact. -3.33. In the year 2011, what is the difference between the Balance of Payment (as % of service exports) in Kazakhstan and Balance of Payment (as % of service exports) in Netherlands?
Provide a short and direct response. -24.18. In the year 2011, what is the difference between the Balance of Payment (as % of service exports) in Kazakhstan and Balance of Payment (as % of service exports) in Singapore?
Offer a very short reply. -12.14. In the year 2011, what is the difference between the Balance of Payment (as % of service exports) of Netherlands and Balance of Payment (as % of service exports) of Singapore?
Your answer should be very brief. 12.03. In the year 2012, what is the difference between the Balance of Payment (as % of service exports) in Low income and Balance of Payment (as % of service exports) in Kazakhstan?
Give a very brief answer. 10.6. In the year 2012, what is the difference between the Balance of Payment (as % of service exports) of Low income and Balance of Payment (as % of service exports) of Netherlands?
Give a very brief answer. -13.25. In the year 2012, what is the difference between the Balance of Payment (as % of service exports) in Low income and Balance of Payment (as % of service exports) in Singapore?
Provide a succinct answer. -3.81. In the year 2012, what is the difference between the Balance of Payment (as % of service exports) in Kazakhstan and Balance of Payment (as % of service exports) in Netherlands?
Your answer should be very brief. -23.85. In the year 2012, what is the difference between the Balance of Payment (as % of service exports) of Kazakhstan and Balance of Payment (as % of service exports) of Singapore?
Offer a very short reply. -14.4. In the year 2012, what is the difference between the Balance of Payment (as % of service exports) of Netherlands and Balance of Payment (as % of service exports) of Singapore?
Provide a succinct answer. 9.45. What is the ratio of the Balance of Payment (as % of service exports) in Low income in 2005 to that in 2007?
Keep it short and to the point. 0.82. What is the ratio of the Balance of Payment (as % of service exports) in Kazakhstan in 2005 to that in 2007?
Your answer should be very brief. 1.08. What is the ratio of the Balance of Payment (as % of service exports) in Singapore in 2005 to that in 2007?
Provide a short and direct response. 0.94. What is the ratio of the Balance of Payment (as % of service exports) of Low income in 2005 to that in 2008?
Your answer should be very brief. 0.77. What is the ratio of the Balance of Payment (as % of service exports) of Kazakhstan in 2005 to that in 2008?
Give a very brief answer. 1.01. What is the ratio of the Balance of Payment (as % of service exports) of Singapore in 2005 to that in 2008?
Offer a very short reply. 0.94. What is the ratio of the Balance of Payment (as % of service exports) of Low income in 2005 to that in 2009?
Your answer should be compact. 0.71. What is the ratio of the Balance of Payment (as % of service exports) of Kazakhstan in 2005 to that in 2009?
Your answer should be very brief. 0.96. What is the ratio of the Balance of Payment (as % of service exports) in Singapore in 2005 to that in 2009?
Provide a short and direct response. 0.89. What is the ratio of the Balance of Payment (as % of service exports) of Low income in 2005 to that in 2010?
Your answer should be compact. 0.69. What is the ratio of the Balance of Payment (as % of service exports) of Kazakhstan in 2005 to that in 2010?
Your response must be concise. 1.03. What is the ratio of the Balance of Payment (as % of service exports) of Netherlands in 2005 to that in 2010?
Provide a succinct answer. 1.02. What is the ratio of the Balance of Payment (as % of service exports) of Singapore in 2005 to that in 2010?
Keep it short and to the point. 0.97. What is the ratio of the Balance of Payment (as % of service exports) in Low income in 2005 to that in 2011?
Keep it short and to the point. 0.69. What is the ratio of the Balance of Payment (as % of service exports) in Kazakhstan in 2005 to that in 2011?
Give a very brief answer. 1.05. What is the ratio of the Balance of Payment (as % of service exports) of Singapore in 2005 to that in 2011?
Make the answer very short. 0.94. What is the ratio of the Balance of Payment (as % of service exports) of Low income in 2005 to that in 2012?
Offer a terse response. 0.65. What is the ratio of the Balance of Payment (as % of service exports) in Kazakhstan in 2005 to that in 2012?
Offer a terse response. 1.1. What is the ratio of the Balance of Payment (as % of service exports) of Netherlands in 2005 to that in 2012?
Your response must be concise. 1.01. What is the ratio of the Balance of Payment (as % of service exports) of Singapore in 2005 to that in 2012?
Your answer should be compact. 0.88. What is the ratio of the Balance of Payment (as % of service exports) of Low income in 2007 to that in 2008?
Provide a short and direct response. 0.94. What is the ratio of the Balance of Payment (as % of service exports) of Kazakhstan in 2007 to that in 2008?
Provide a short and direct response. 0.94. What is the ratio of the Balance of Payment (as % of service exports) in Low income in 2007 to that in 2009?
Keep it short and to the point. 0.86. What is the ratio of the Balance of Payment (as % of service exports) of Kazakhstan in 2007 to that in 2009?
Your answer should be compact. 0.89. What is the ratio of the Balance of Payment (as % of service exports) in Singapore in 2007 to that in 2009?
Keep it short and to the point. 0.95. What is the ratio of the Balance of Payment (as % of service exports) in Low income in 2007 to that in 2010?
Your response must be concise. 0.84. What is the ratio of the Balance of Payment (as % of service exports) of Kazakhstan in 2007 to that in 2010?
Ensure brevity in your answer.  0.96. What is the ratio of the Balance of Payment (as % of service exports) in Netherlands in 2007 to that in 2010?
Offer a terse response. 1.02. What is the ratio of the Balance of Payment (as % of service exports) of Singapore in 2007 to that in 2010?
Provide a short and direct response. 1.04. What is the ratio of the Balance of Payment (as % of service exports) of Low income in 2007 to that in 2011?
Provide a short and direct response. 0.84. What is the ratio of the Balance of Payment (as % of service exports) of Kazakhstan in 2007 to that in 2011?
Ensure brevity in your answer.  0.98. What is the ratio of the Balance of Payment (as % of service exports) in Netherlands in 2007 to that in 2011?
Your response must be concise. 0.99. What is the ratio of the Balance of Payment (as % of service exports) in Singapore in 2007 to that in 2011?
Provide a short and direct response. 1.01. What is the ratio of the Balance of Payment (as % of service exports) in Low income in 2007 to that in 2012?
Keep it short and to the point. 0.79. What is the ratio of the Balance of Payment (as % of service exports) of Kazakhstan in 2007 to that in 2012?
Provide a short and direct response. 1.02. What is the ratio of the Balance of Payment (as % of service exports) in Netherlands in 2007 to that in 2012?
Ensure brevity in your answer.  1.01. What is the ratio of the Balance of Payment (as % of service exports) in Singapore in 2007 to that in 2012?
Give a very brief answer. 0.94. What is the ratio of the Balance of Payment (as % of service exports) of Low income in 2008 to that in 2009?
Provide a short and direct response. 0.92. What is the ratio of the Balance of Payment (as % of service exports) in Kazakhstan in 2008 to that in 2009?
Give a very brief answer. 0.95. What is the ratio of the Balance of Payment (as % of service exports) in Netherlands in 2008 to that in 2009?
Keep it short and to the point. 1. What is the ratio of the Balance of Payment (as % of service exports) of Singapore in 2008 to that in 2009?
Your answer should be very brief. 0.95. What is the ratio of the Balance of Payment (as % of service exports) of Low income in 2008 to that in 2010?
Give a very brief answer. 0.89. What is the ratio of the Balance of Payment (as % of service exports) of Kazakhstan in 2008 to that in 2010?
Your response must be concise. 1.02. What is the ratio of the Balance of Payment (as % of service exports) of Netherlands in 2008 to that in 2010?
Make the answer very short. 1.02. What is the ratio of the Balance of Payment (as % of service exports) in Singapore in 2008 to that in 2010?
Ensure brevity in your answer.  1.03. What is the ratio of the Balance of Payment (as % of service exports) in Low income in 2008 to that in 2011?
Provide a succinct answer. 0.9. What is the ratio of the Balance of Payment (as % of service exports) in Kazakhstan in 2008 to that in 2011?
Your answer should be very brief. 1.04. What is the ratio of the Balance of Payment (as % of service exports) of Netherlands in 2008 to that in 2011?
Keep it short and to the point. 0.99. What is the ratio of the Balance of Payment (as % of service exports) of Singapore in 2008 to that in 2011?
Ensure brevity in your answer.  1. What is the ratio of the Balance of Payment (as % of service exports) in Low income in 2008 to that in 2012?
Provide a succinct answer. 0.84. What is the ratio of the Balance of Payment (as % of service exports) of Kazakhstan in 2008 to that in 2012?
Give a very brief answer. 1.09. What is the ratio of the Balance of Payment (as % of service exports) of Netherlands in 2008 to that in 2012?
Offer a very short reply. 1.01. What is the ratio of the Balance of Payment (as % of service exports) of Singapore in 2008 to that in 2012?
Your answer should be compact. 0.93. What is the ratio of the Balance of Payment (as % of service exports) of Low income in 2009 to that in 2010?
Your answer should be compact. 0.97. What is the ratio of the Balance of Payment (as % of service exports) in Kazakhstan in 2009 to that in 2010?
Your answer should be compact. 1.07. What is the ratio of the Balance of Payment (as % of service exports) of Netherlands in 2009 to that in 2010?
Provide a succinct answer. 1.02. What is the ratio of the Balance of Payment (as % of service exports) of Singapore in 2009 to that in 2010?
Your answer should be very brief. 1.09. What is the ratio of the Balance of Payment (as % of service exports) in Low income in 2009 to that in 2011?
Make the answer very short. 0.98. What is the ratio of the Balance of Payment (as % of service exports) in Kazakhstan in 2009 to that in 2011?
Provide a succinct answer. 1.1. What is the ratio of the Balance of Payment (as % of service exports) in Netherlands in 2009 to that in 2011?
Make the answer very short. 0.99. What is the ratio of the Balance of Payment (as % of service exports) of Singapore in 2009 to that in 2011?
Give a very brief answer. 1.06. What is the ratio of the Balance of Payment (as % of service exports) in Low income in 2009 to that in 2012?
Your answer should be very brief. 0.92. What is the ratio of the Balance of Payment (as % of service exports) in Kazakhstan in 2009 to that in 2012?
Ensure brevity in your answer.  1.14. What is the ratio of the Balance of Payment (as % of service exports) of Netherlands in 2009 to that in 2012?
Offer a terse response. 1.01. What is the ratio of the Balance of Payment (as % of service exports) of Singapore in 2009 to that in 2012?
Offer a terse response. 0.99. What is the ratio of the Balance of Payment (as % of service exports) of Low income in 2010 to that in 2011?
Make the answer very short. 1.01. What is the ratio of the Balance of Payment (as % of service exports) of Kazakhstan in 2010 to that in 2011?
Ensure brevity in your answer.  1.02. What is the ratio of the Balance of Payment (as % of service exports) in Netherlands in 2010 to that in 2011?
Provide a short and direct response. 0.96. What is the ratio of the Balance of Payment (as % of service exports) of Singapore in 2010 to that in 2011?
Provide a short and direct response. 0.97. What is the ratio of the Balance of Payment (as % of service exports) in Low income in 2010 to that in 2012?
Your response must be concise. 0.94. What is the ratio of the Balance of Payment (as % of service exports) in Kazakhstan in 2010 to that in 2012?
Offer a terse response. 1.07. What is the ratio of the Balance of Payment (as % of service exports) of Netherlands in 2010 to that in 2012?
Offer a very short reply. 0.99. What is the ratio of the Balance of Payment (as % of service exports) of Singapore in 2010 to that in 2012?
Offer a very short reply. 0.91. What is the ratio of the Balance of Payment (as % of service exports) in Low income in 2011 to that in 2012?
Your answer should be compact. 0.94. What is the ratio of the Balance of Payment (as % of service exports) in Kazakhstan in 2011 to that in 2012?
Keep it short and to the point. 1.04. What is the ratio of the Balance of Payment (as % of service exports) in Singapore in 2011 to that in 2012?
Give a very brief answer. 0.93. What is the difference between the highest and the second highest Balance of Payment (as % of service exports) of Low income?
Offer a terse response. 1.2. What is the difference between the highest and the second highest Balance of Payment (as % of service exports) of Kazakhstan?
Your response must be concise. 0.48. What is the difference between the highest and the second highest Balance of Payment (as % of service exports) in Netherlands?
Ensure brevity in your answer.  0.43. What is the difference between the highest and the second highest Balance of Payment (as % of service exports) in Singapore?
Provide a short and direct response. 0.32. What is the difference between the highest and the lowest Balance of Payment (as % of service exports) in Low income?
Your answer should be compact. 7.52. What is the difference between the highest and the lowest Balance of Payment (as % of service exports) in Kazakhstan?
Keep it short and to the point. 1.56. What is the difference between the highest and the lowest Balance of Payment (as % of service exports) in Netherlands?
Your answer should be compact. 1.28. What is the difference between the highest and the lowest Balance of Payment (as % of service exports) of Singapore?
Offer a terse response. 3.12. 